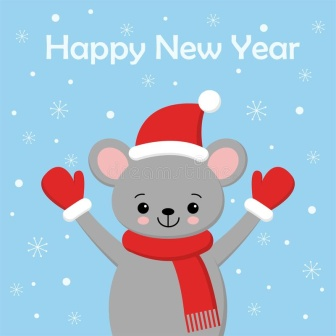Can you describe the mood and emotions the image conveys? The mood of the image is undoubtedly joyful and festive. The mouse’s wide smile and raised arms convey a sense of excitement and celebration. Its attire, consisting of bright red mittens and a Santa hat, adds to the festive feel, while the background with its light blue hue and falling snowflakes create a peaceful wintery atmosphere. The 'Happy New Year' greeting further enhances the mood of joyous anticipation and happiness. Overall, the image exudes a warm, cheerful, and celebratory vibe, perfect for ringing in the new year. 